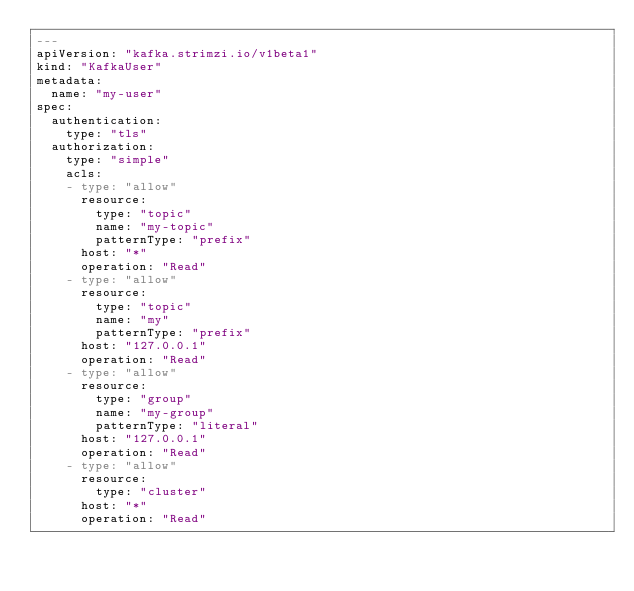Convert code to text. <code><loc_0><loc_0><loc_500><loc_500><_YAML_>---
apiVersion: "kafka.strimzi.io/v1beta1"
kind: "KafkaUser"
metadata:
  name: "my-user"
spec:
  authentication:
    type: "tls"
  authorization:
    type: "simple"
    acls:
    - type: "allow"
      resource:
        type: "topic"
        name: "my-topic"
        patternType: "prefix"
      host: "*"
      operation: "Read"
    - type: "allow"
      resource:
        type: "topic"
        name: "my"
        patternType: "prefix"
      host: "127.0.0.1"
      operation: "Read"
    - type: "allow"
      resource:
        type: "group"
        name: "my-group"
        patternType: "literal"
      host: "127.0.0.1"
      operation: "Read"
    - type: "allow"
      resource:
        type: "cluster"
      host: "*"
      operation: "Read"</code> 